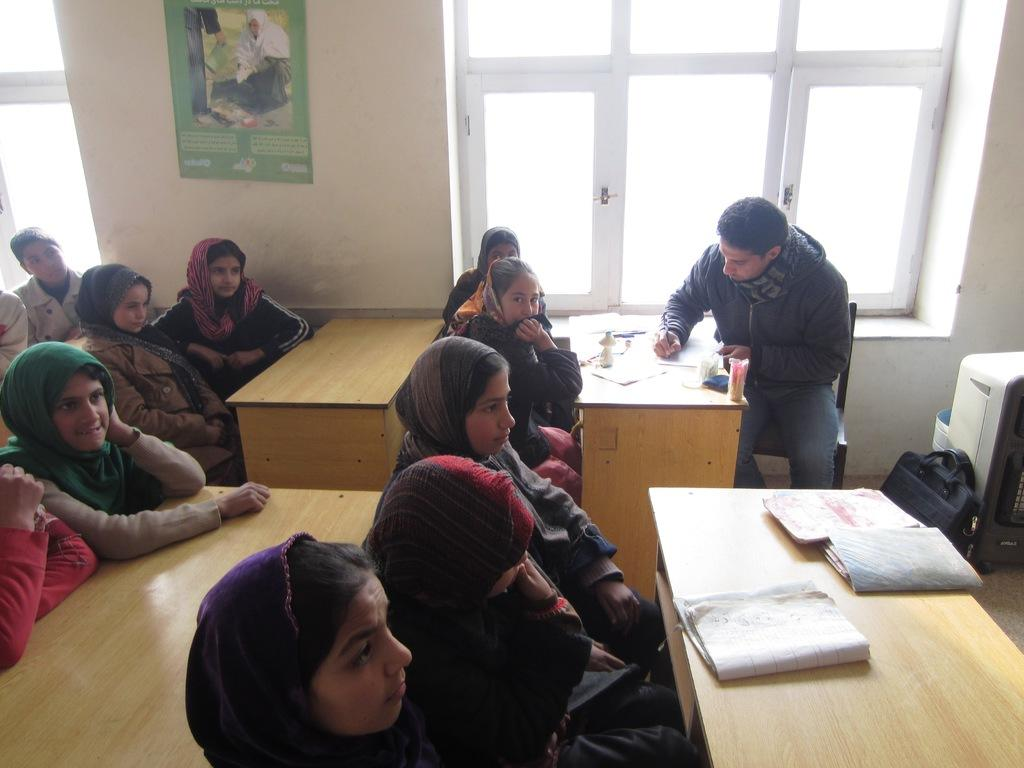What type of furniture is present in the image? There are tables in the image. What are the people sitting on in the image? People are sitting on chairs in the image. What objects can be seen on the tables? There are books on the tables. What can be seen through the windows in the image? Windows are visible in the image, but the conversation does not provide information about what can be seen through them. Can you describe the squirrel climbing the silk curtains in the image? There is no squirrel or silk curtains present in the image. How does the wind affect the people sitting on the chairs in the image? The conversation does not provide information about the presence of wind in the image. 